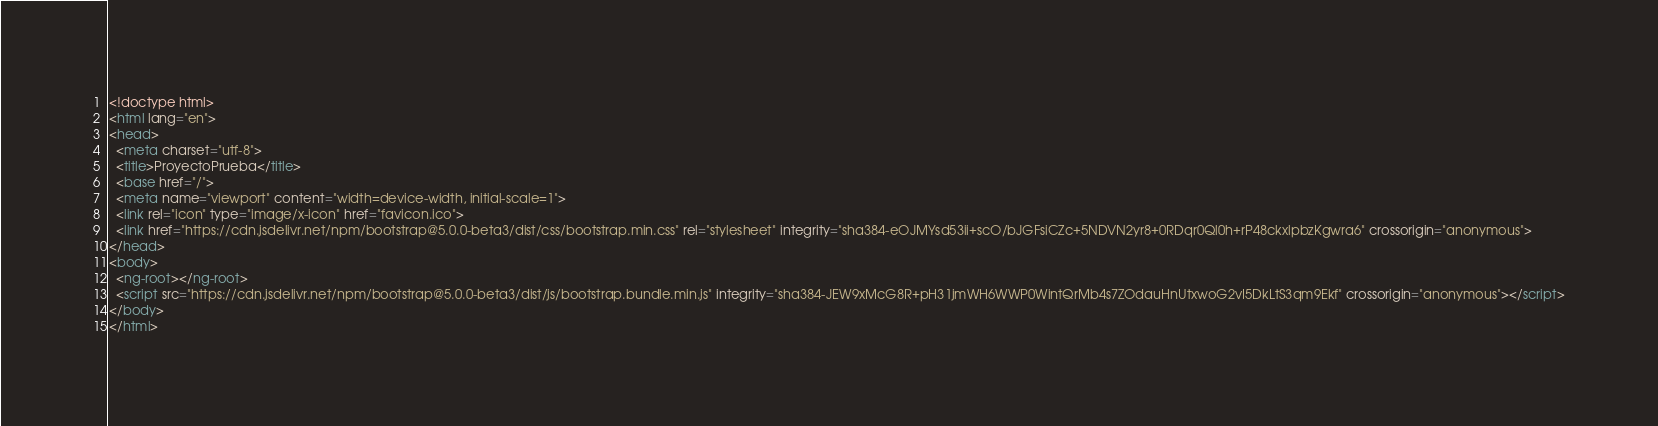Convert code to text. <code><loc_0><loc_0><loc_500><loc_500><_HTML_><!doctype html>
<html lang="en">
<head>
  <meta charset="utf-8">
  <title>ProyectoPrueba</title>
  <base href="/">
  <meta name="viewport" content="width=device-width, initial-scale=1">
  <link rel="icon" type="image/x-icon" href="favicon.ico">
  <link href="https://cdn.jsdelivr.net/npm/bootstrap@5.0.0-beta3/dist/css/bootstrap.min.css" rel="stylesheet" integrity="sha384-eOJMYsd53ii+scO/bJGFsiCZc+5NDVN2yr8+0RDqr0Ql0h+rP48ckxlpbzKgwra6" crossorigin="anonymous">
</head>
<body>
  <ng-root></ng-root>
  <script src="https://cdn.jsdelivr.net/npm/bootstrap@5.0.0-beta3/dist/js/bootstrap.bundle.min.js" integrity="sha384-JEW9xMcG8R+pH31jmWH6WWP0WintQrMb4s7ZOdauHnUtxwoG2vI5DkLtS3qm9Ekf" crossorigin="anonymous"></script>
</body>
</html>
</code> 